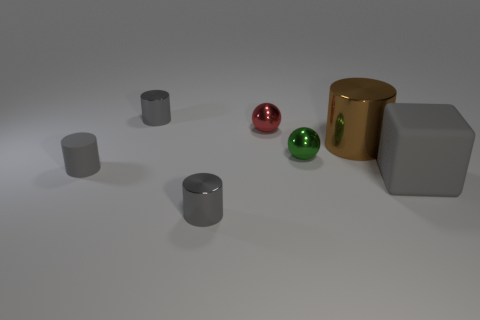Are there fewer large brown metal cylinders that are in front of the matte cylinder than large brown things that are behind the big gray rubber cube?
Your answer should be very brief. Yes. How many other objects are there of the same material as the cube?
Keep it short and to the point. 1. There is a gray cube that is the same size as the brown cylinder; what is it made of?
Offer a very short reply. Rubber. How many gray objects are tiny metallic cylinders or tiny matte cylinders?
Provide a short and direct response. 3. What color is the metal cylinder that is both behind the green thing and on the left side of the big brown thing?
Your answer should be compact. Gray. Does the small thing that is in front of the small gray matte thing have the same material as the cylinder right of the green sphere?
Your answer should be compact. Yes. Is the number of large things on the right side of the brown metal cylinder greater than the number of small matte cylinders in front of the large gray rubber thing?
Offer a terse response. Yes. What shape is the brown object that is the same size as the matte block?
Offer a very short reply. Cylinder. What number of things are tiny gray cylinders or small gray cylinders that are behind the red metal thing?
Offer a very short reply. 3. Is the tiny matte cylinder the same color as the big matte cube?
Ensure brevity in your answer.  Yes. 